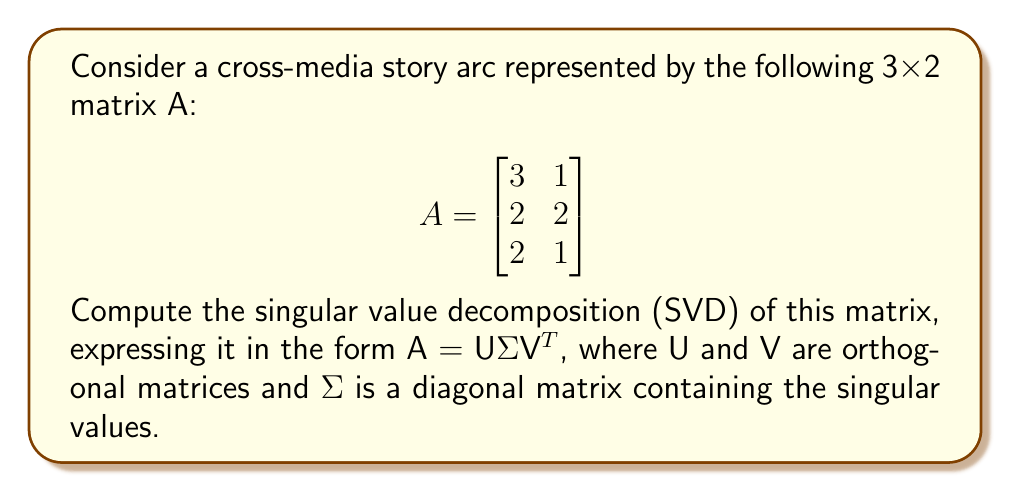Provide a solution to this math problem. To compute the singular value decomposition (SVD) of matrix A, we'll follow these steps:

1. Calculate A^T A and AA^T:
   $$ A^T A = \begin{bmatrix}
   3 & 2 & 2 \\
   1 & 2 & 1
   \end{bmatrix} \begin{bmatrix}
   3 & 1 \\
   2 & 2 \\
   2 & 1
   \end{bmatrix} = \begin{bmatrix}
   17 & 11 \\
   11 & 6
   \end{bmatrix} $$
   
   $$ AA^T = \begin{bmatrix}
   3 & 1 \\
   2 & 2 \\
   2 & 1
   \end{bmatrix} \begin{bmatrix}
   3 & 2 & 2 \\
   1 & 2 & 1
   \end{bmatrix} = \begin{bmatrix}
   10 & 7 & 7 \\
   7 & 8 & 6 \\
   7 & 6 & 5
   \end{bmatrix} $$

2. Find eigenvalues of A^T A:
   $\det(A^T A - \lambda I) = \begin{vmatrix}
   17-\lambda & 11 \\
   11 & 6-\lambda
   \end{vmatrix} = (17-\lambda)(6-\lambda) - 121 = \lambda^2 - 23\lambda + 1 = 0$
   
   Solving this equation: $\lambda_1 \approx 22.81$ and $\lambda_2 \approx 0.19$

3. Calculate singular values:
   $\sigma_1 = \sqrt{\lambda_1} \approx 4.78$ and $\sigma_2 = \sqrt{\lambda_2} \approx 0.44$

4. Find eigenvectors of A^T A (columns of V):
   For $\lambda_1 \approx 22.81$:
   $(A^T A - 22.81I)v_1 = 0$ gives $v_1 \approx [0.84, 0.54]^T$
   
   For $\lambda_2 \approx 0.19$:
   $(A^T A - 0.19I)v_2 = 0$ gives $v_2 \approx [-0.54, 0.84]^T$

5. Find eigenvectors of AA^T (columns of U):
   $u_1 = \frac{1}{\sigma_1}Av_1 \approx [0.59, 0.57, 0.57]^T$
   $u_2 = \frac{1}{\sigma_2}Av_2 \approx [-0.07, 0.71, -0.70]^T$
   
   The third column of U is the cross product of the first two:
   $u_3 = u_1 \times u_2 \approx [0.81, -0.41, -0.42]^T$

6. Construct U, Σ, and V matrices:
   $$ U \approx \begin{bmatrix}
   0.59 & -0.07 & 0.81 \\
   0.57 & 0.71 & -0.41 \\
   0.57 & -0.70 & -0.42
   \end{bmatrix} $$
   
   $$ \Sigma = \begin{bmatrix}
   4.78 & 0 \\
   0 & 0.44 \\
   0 & 0
   \end{bmatrix} $$
   
   $$ V \approx \begin{bmatrix}
   0.84 & -0.54 \\
   0.54 & 0.84
   \end{bmatrix} $$
Answer: $A = U\Sigma V^T$, where:
$$ U \approx \begin{bmatrix}
0.59 & -0.07 & 0.81 \\
0.57 & 0.71 & -0.41 \\
0.57 & -0.70 & -0.42
\end{bmatrix}, \Sigma = \begin{bmatrix}
4.78 & 0 \\
0 & 0.44 \\
0 & 0
\end{bmatrix}, V \approx \begin{bmatrix}
0.84 & -0.54 \\
0.54 & 0.84
\end{bmatrix} $$ 